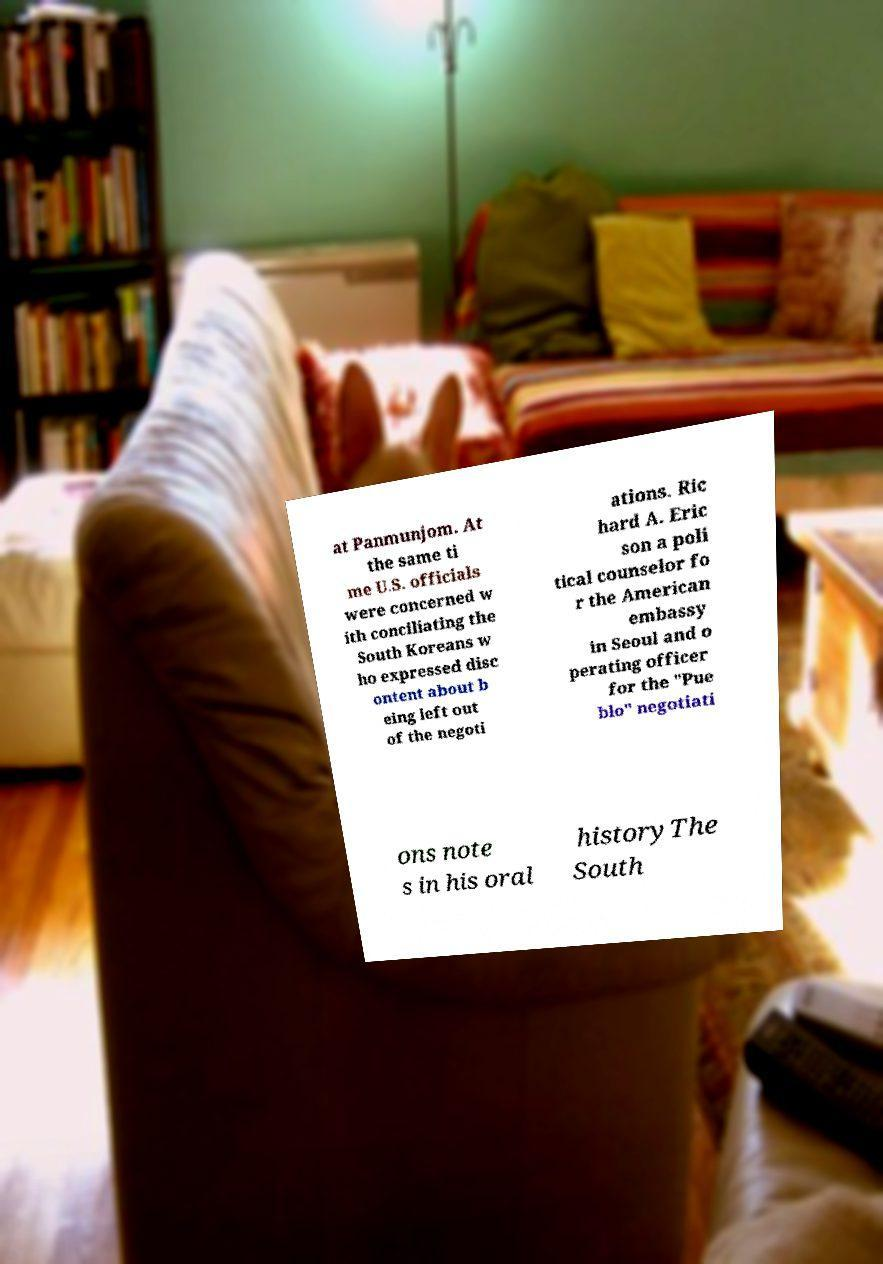Could you assist in decoding the text presented in this image and type it out clearly? at Panmunjom. At the same ti me U.S. officials were concerned w ith conciliating the South Koreans w ho expressed disc ontent about b eing left out of the negoti ations. Ric hard A. Eric son a poli tical counselor fo r the American embassy in Seoul and o perating officer for the "Pue blo" negotiati ons note s in his oral historyThe South 